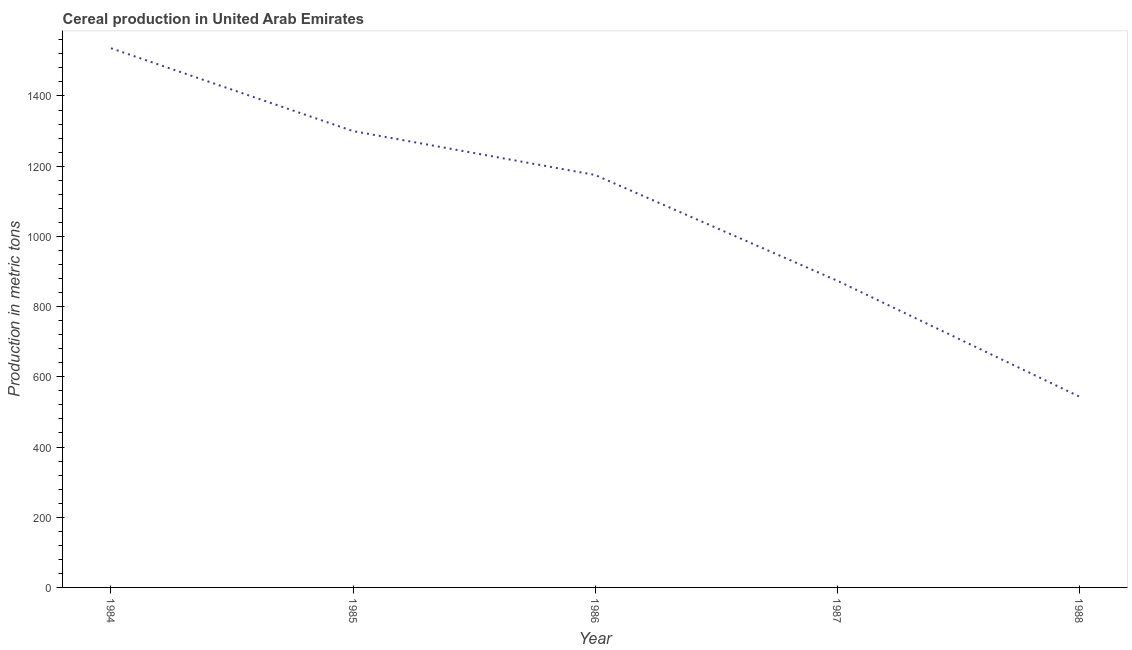What is the cereal production in 1986?
Your answer should be compact. 1175. Across all years, what is the maximum cereal production?
Make the answer very short. 1536. Across all years, what is the minimum cereal production?
Offer a very short reply. 544. In which year was the cereal production maximum?
Your response must be concise. 1984. What is the sum of the cereal production?
Your response must be concise. 5429. What is the difference between the cereal production in 1987 and 1988?
Ensure brevity in your answer.  330. What is the average cereal production per year?
Keep it short and to the point. 1085.8. What is the median cereal production?
Offer a very short reply. 1175. In how many years, is the cereal production greater than 1240 metric tons?
Your answer should be compact. 2. Do a majority of the years between 1987 and 1984 (inclusive) have cereal production greater than 800 metric tons?
Provide a short and direct response. Yes. What is the ratio of the cereal production in 1987 to that in 1988?
Keep it short and to the point. 1.61. Is the cereal production in 1984 less than that in 1988?
Provide a succinct answer. No. Is the difference between the cereal production in 1986 and 1987 greater than the difference between any two years?
Your answer should be very brief. No. What is the difference between the highest and the second highest cereal production?
Ensure brevity in your answer.  236. What is the difference between the highest and the lowest cereal production?
Ensure brevity in your answer.  992. In how many years, is the cereal production greater than the average cereal production taken over all years?
Your response must be concise. 3. How many years are there in the graph?
Your answer should be very brief. 5. What is the title of the graph?
Ensure brevity in your answer.  Cereal production in United Arab Emirates. What is the label or title of the Y-axis?
Provide a short and direct response. Production in metric tons. What is the Production in metric tons in 1984?
Provide a short and direct response. 1536. What is the Production in metric tons in 1985?
Give a very brief answer. 1300. What is the Production in metric tons in 1986?
Offer a very short reply. 1175. What is the Production in metric tons of 1987?
Provide a short and direct response. 874. What is the Production in metric tons in 1988?
Your answer should be compact. 544. What is the difference between the Production in metric tons in 1984 and 1985?
Ensure brevity in your answer.  236. What is the difference between the Production in metric tons in 1984 and 1986?
Your answer should be very brief. 361. What is the difference between the Production in metric tons in 1984 and 1987?
Keep it short and to the point. 662. What is the difference between the Production in metric tons in 1984 and 1988?
Provide a succinct answer. 992. What is the difference between the Production in metric tons in 1985 and 1986?
Ensure brevity in your answer.  125. What is the difference between the Production in metric tons in 1985 and 1987?
Your answer should be very brief. 426. What is the difference between the Production in metric tons in 1985 and 1988?
Your response must be concise. 756. What is the difference between the Production in metric tons in 1986 and 1987?
Offer a terse response. 301. What is the difference between the Production in metric tons in 1986 and 1988?
Your answer should be very brief. 631. What is the difference between the Production in metric tons in 1987 and 1988?
Your answer should be compact. 330. What is the ratio of the Production in metric tons in 1984 to that in 1985?
Provide a succinct answer. 1.18. What is the ratio of the Production in metric tons in 1984 to that in 1986?
Offer a very short reply. 1.31. What is the ratio of the Production in metric tons in 1984 to that in 1987?
Offer a very short reply. 1.76. What is the ratio of the Production in metric tons in 1984 to that in 1988?
Give a very brief answer. 2.82. What is the ratio of the Production in metric tons in 1985 to that in 1986?
Your response must be concise. 1.11. What is the ratio of the Production in metric tons in 1985 to that in 1987?
Your answer should be very brief. 1.49. What is the ratio of the Production in metric tons in 1985 to that in 1988?
Make the answer very short. 2.39. What is the ratio of the Production in metric tons in 1986 to that in 1987?
Provide a short and direct response. 1.34. What is the ratio of the Production in metric tons in 1986 to that in 1988?
Your answer should be very brief. 2.16. What is the ratio of the Production in metric tons in 1987 to that in 1988?
Keep it short and to the point. 1.61. 